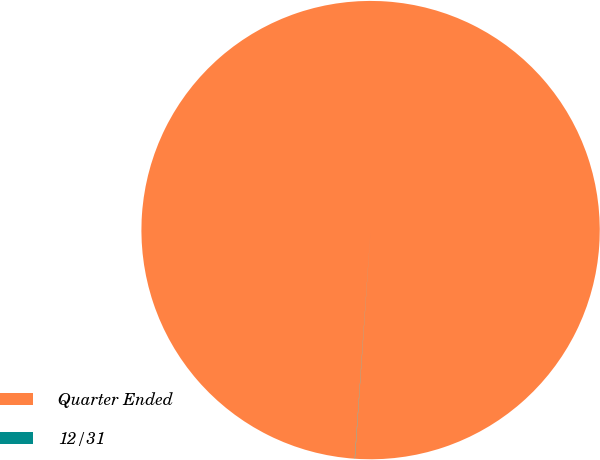Convert chart to OTSL. <chart><loc_0><loc_0><loc_500><loc_500><pie_chart><fcel>Quarter Ended<fcel>12/31<nl><fcel>99.98%<fcel>0.02%<nl></chart> 